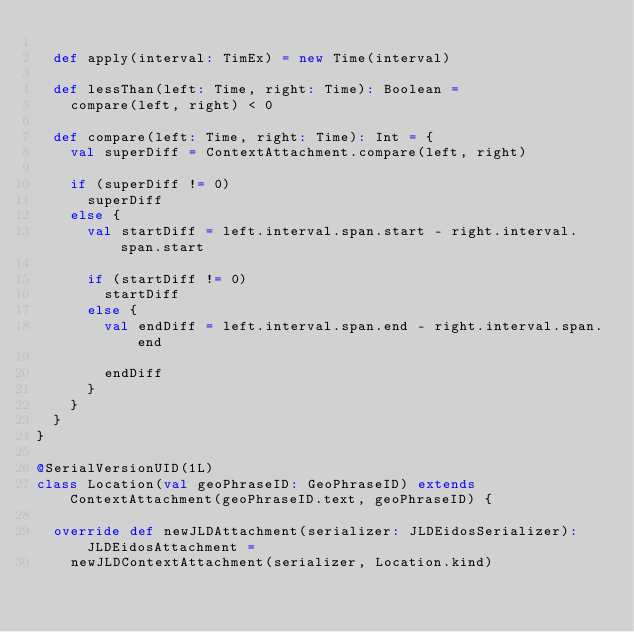Convert code to text. <code><loc_0><loc_0><loc_500><loc_500><_Scala_>
  def apply(interval: TimEx) = new Time(interval)

  def lessThan(left: Time, right: Time): Boolean =
    compare(left, right) < 0

  def compare(left: Time, right: Time): Int = {
    val superDiff = ContextAttachment.compare(left, right)

    if (superDiff != 0)
      superDiff
    else {
      val startDiff = left.interval.span.start - right.interval.span.start

      if (startDiff != 0)
        startDiff
      else {
        val endDiff = left.interval.span.end - right.interval.span.end

        endDiff
      }
    }
  }
}

@SerialVersionUID(1L)
class Location(val geoPhraseID: GeoPhraseID) extends ContextAttachment(geoPhraseID.text, geoPhraseID) {

  override def newJLDAttachment(serializer: JLDEidosSerializer): JLDEidosAttachment =
    newJLDContextAttachment(serializer, Location.kind)
</code> 